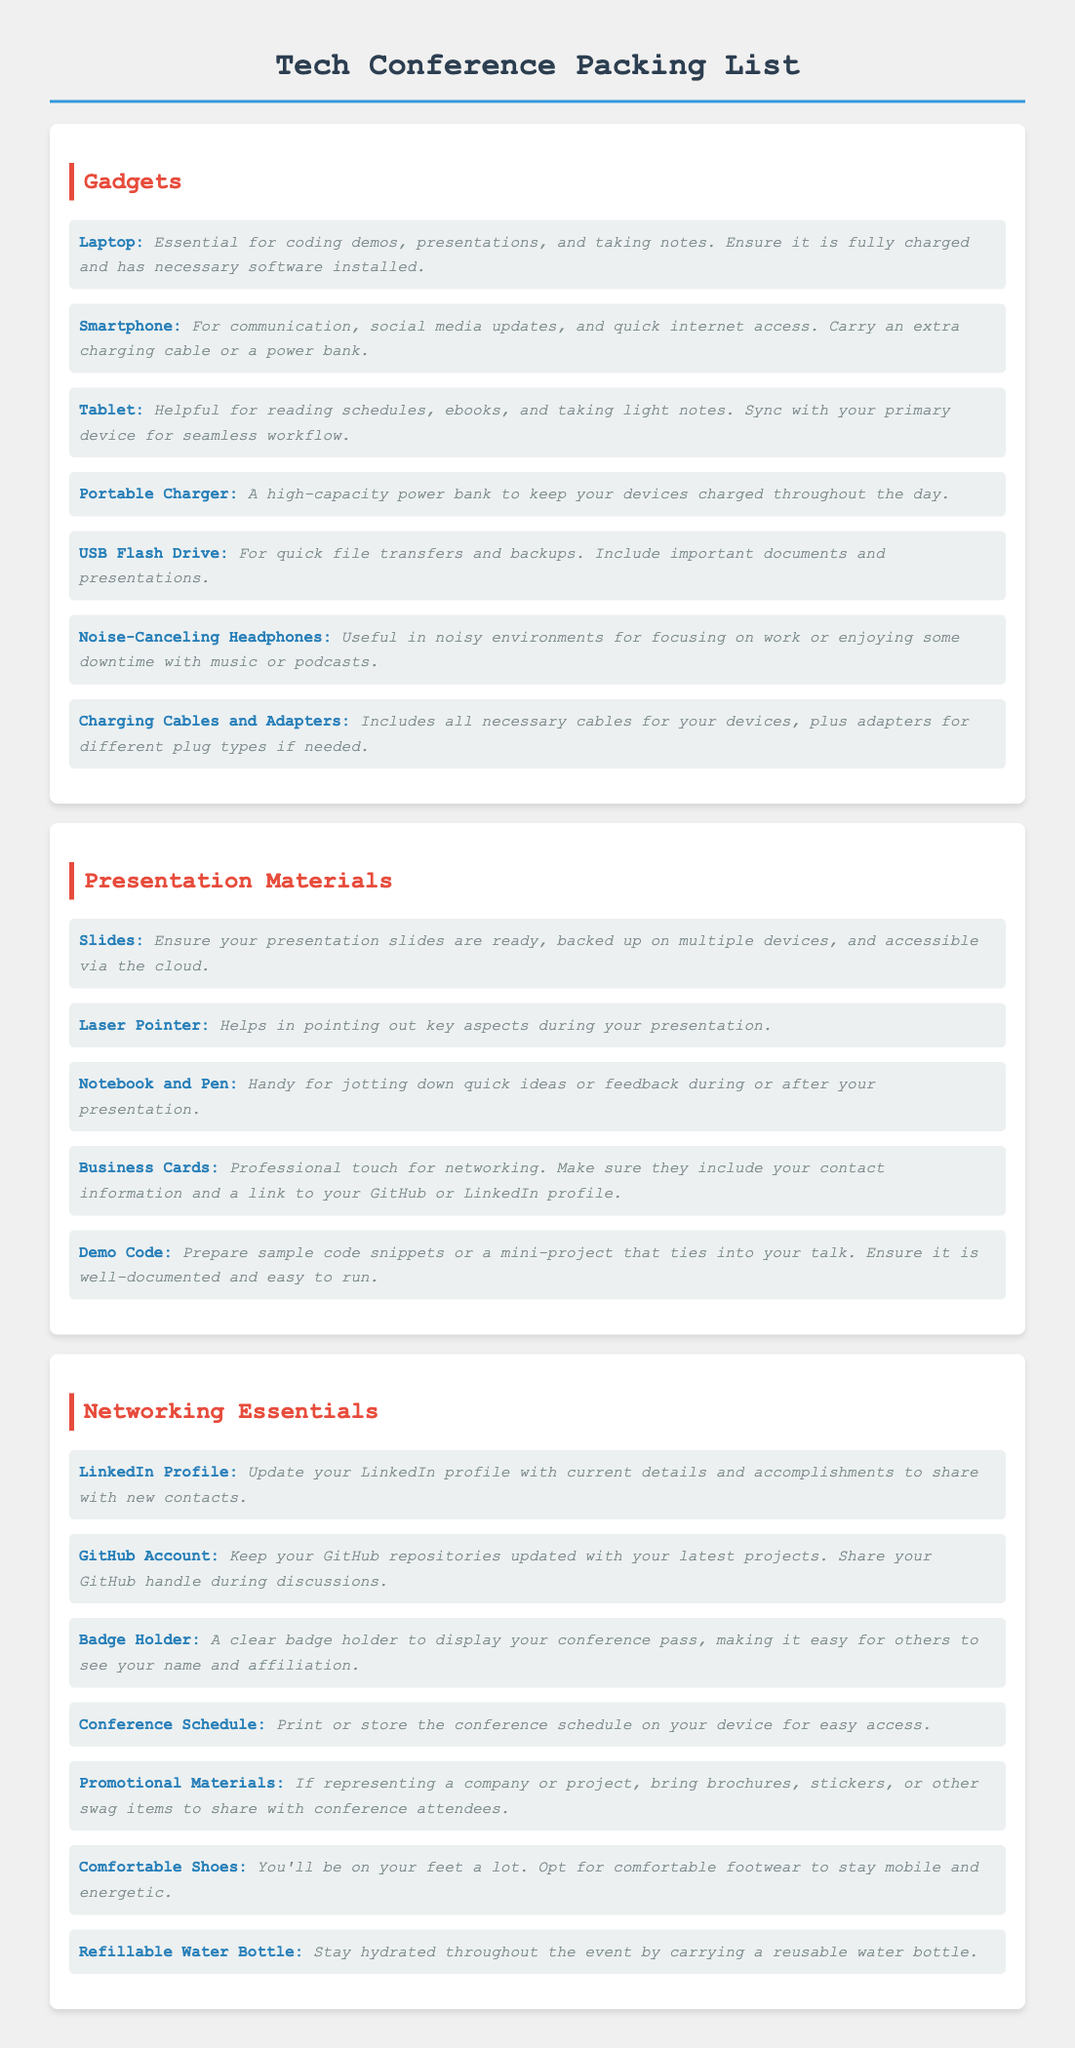what is the first item listed under Gadgets? The first item listed under Gadgets is Laptop, which is essential for coding demos, presentations, and taking notes.
Answer: Laptop how many items are recommended in the Presentation Materials section? The Presentation Materials section lists five items that are recommended for attendees.
Answer: 5 what type of headphones are suggested in the Gadgets section? The suggested type of headphones in the Gadgets section is Noise-Canceling Headphones, useful in noisy environments.
Answer: Noise-Canceling Headphones what should be included on your Business Cards according to the document? The document specifies that Business Cards should include your contact information and a link to your GitHub or LinkedIn profile for a professional touch.
Answer: Contact information and link to GitHub or LinkedIn name one item that is specifically for networking. One item specifically for networking mentioned in the document is the GitHub Account, which should be updated with your latest projects.
Answer: GitHub Account how many items are listed in the Networking Essentials section? The Networking Essentials section contains seven items for attendees to carry for effective networking.
Answer: 7 what is recommended for staying hydrated during the conference? The document recommends carrying a Reusable Water Bottle to stay hydrated throughout the event.
Answer: Reusable Water Bottle which gadget helps with quick file transfers? The gadget that helps with quick file transfers mentioned in the document is a USB Flash Drive.
Answer: USB Flash Drive what should you bring if representing a company? The document suggests bringing Promotional Materials like brochures, stickers, or other swag items if representing a company.
Answer: Promotional Materials 